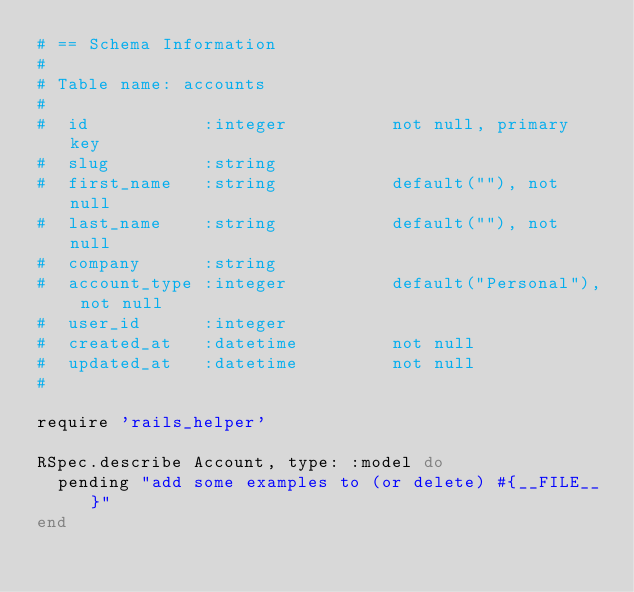Convert code to text. <code><loc_0><loc_0><loc_500><loc_500><_Ruby_># == Schema Information
#
# Table name: accounts
#
#  id           :integer          not null, primary key
#  slug         :string
#  first_name   :string           default(""), not null
#  last_name    :string           default(""), not null
#  company      :string
#  account_type :integer          default("Personal"), not null
#  user_id      :integer
#  created_at   :datetime         not null
#  updated_at   :datetime         not null
#

require 'rails_helper'

RSpec.describe Account, type: :model do
  pending "add some examples to (or delete) #{__FILE__}"
end
</code> 